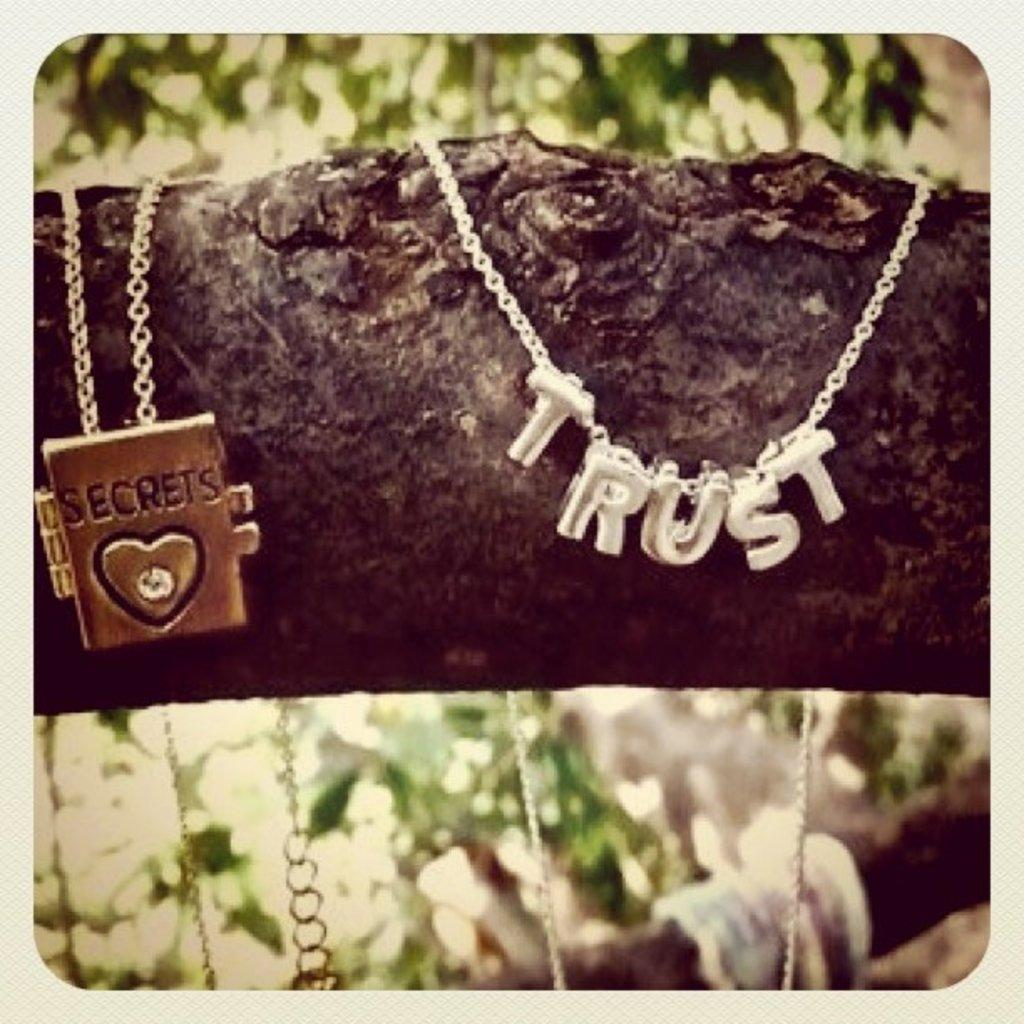<image>
Present a compact description of the photo's key features. A necklace with the word TRUST hangs on a tree branch. 